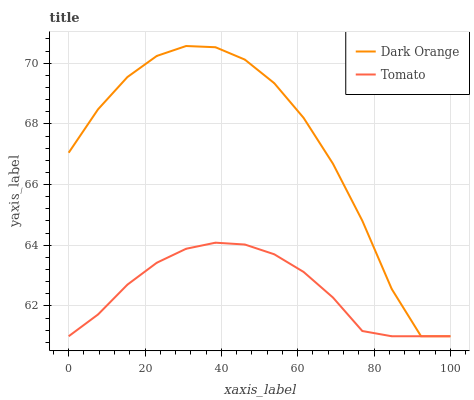Does Tomato have the minimum area under the curve?
Answer yes or no. Yes. Does Dark Orange have the maximum area under the curve?
Answer yes or no. Yes. Does Dark Orange have the minimum area under the curve?
Answer yes or no. No. Is Tomato the smoothest?
Answer yes or no. Yes. Is Dark Orange the roughest?
Answer yes or no. Yes. Is Dark Orange the smoothest?
Answer yes or no. No. Does Tomato have the lowest value?
Answer yes or no. Yes. Does Dark Orange have the highest value?
Answer yes or no. Yes. Does Tomato intersect Dark Orange?
Answer yes or no. Yes. Is Tomato less than Dark Orange?
Answer yes or no. No. Is Tomato greater than Dark Orange?
Answer yes or no. No. 